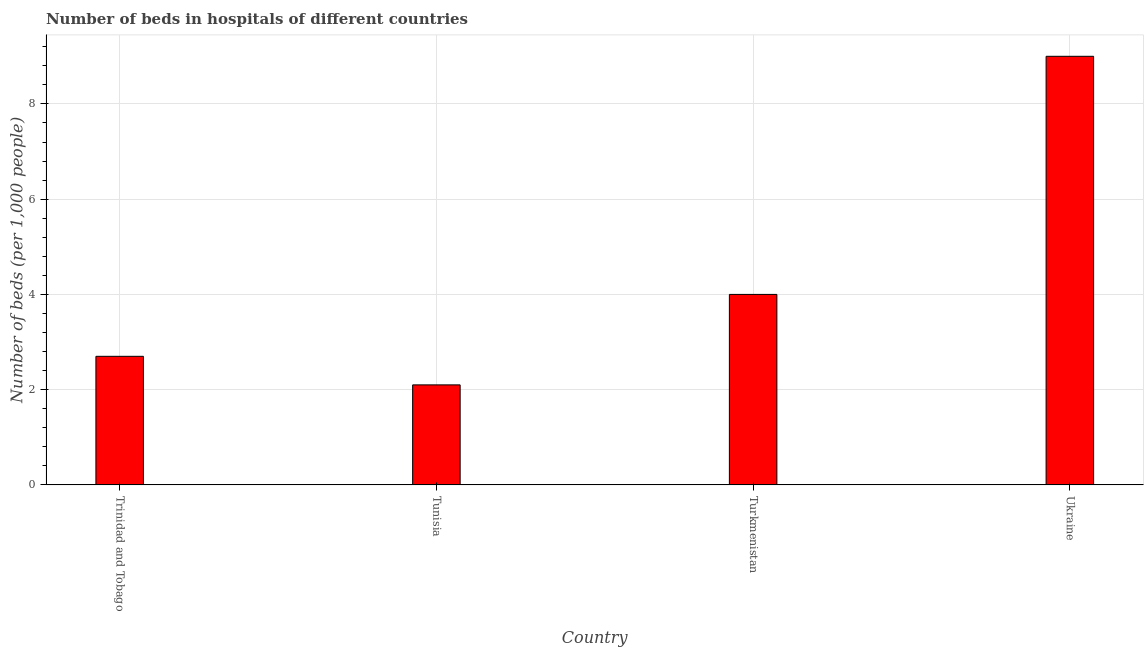Does the graph contain grids?
Ensure brevity in your answer.  Yes. What is the title of the graph?
Your response must be concise. Number of beds in hospitals of different countries. What is the label or title of the X-axis?
Your answer should be compact. Country. What is the label or title of the Y-axis?
Offer a terse response. Number of beds (per 1,0 people). Across all countries, what is the maximum number of hospital beds?
Provide a short and direct response. 9. Across all countries, what is the minimum number of hospital beds?
Offer a terse response. 2.1. In which country was the number of hospital beds maximum?
Provide a short and direct response. Ukraine. In which country was the number of hospital beds minimum?
Ensure brevity in your answer.  Tunisia. What is the average number of hospital beds per country?
Ensure brevity in your answer.  4.45. What is the median number of hospital beds?
Make the answer very short. 3.35. Is the number of hospital beds in Tunisia less than that in Turkmenistan?
Provide a succinct answer. Yes. Is the difference between the number of hospital beds in Trinidad and Tobago and Tunisia greater than the difference between any two countries?
Provide a short and direct response. No. What is the difference between the highest and the second highest number of hospital beds?
Offer a terse response. 5. What is the difference between the highest and the lowest number of hospital beds?
Your answer should be very brief. 6.9. In how many countries, is the number of hospital beds greater than the average number of hospital beds taken over all countries?
Keep it short and to the point. 1. Are all the bars in the graph horizontal?
Offer a very short reply. No. What is the difference between two consecutive major ticks on the Y-axis?
Provide a succinct answer. 2. Are the values on the major ticks of Y-axis written in scientific E-notation?
Your answer should be compact. No. What is the Number of beds (per 1,000 people) in Tunisia?
Keep it short and to the point. 2.1. What is the Number of beds (per 1,000 people) of Turkmenistan?
Offer a terse response. 4. What is the difference between the Number of beds (per 1,000 people) in Trinidad and Tobago and Tunisia?
Give a very brief answer. 0.6. What is the difference between the Number of beds (per 1,000 people) in Trinidad and Tobago and Ukraine?
Give a very brief answer. -6.3. What is the difference between the Number of beds (per 1,000 people) in Turkmenistan and Ukraine?
Ensure brevity in your answer.  -5. What is the ratio of the Number of beds (per 1,000 people) in Trinidad and Tobago to that in Tunisia?
Offer a terse response. 1.29. What is the ratio of the Number of beds (per 1,000 people) in Trinidad and Tobago to that in Turkmenistan?
Give a very brief answer. 0.68. What is the ratio of the Number of beds (per 1,000 people) in Tunisia to that in Turkmenistan?
Offer a very short reply. 0.53. What is the ratio of the Number of beds (per 1,000 people) in Tunisia to that in Ukraine?
Offer a terse response. 0.23. What is the ratio of the Number of beds (per 1,000 people) in Turkmenistan to that in Ukraine?
Offer a very short reply. 0.44. 